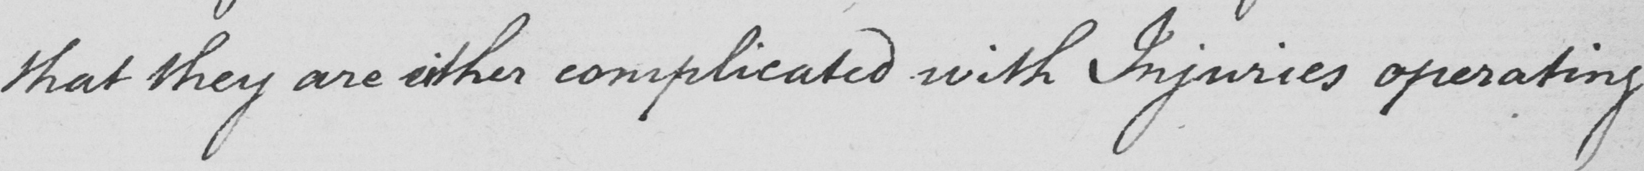Please provide the text content of this handwritten line. that they are either complicated with Inquiries operating 